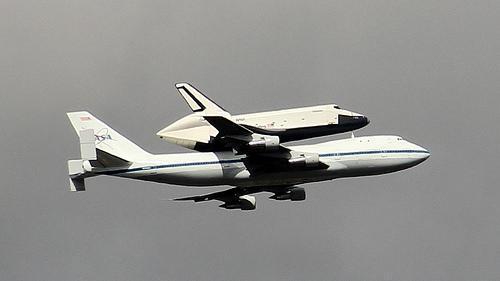How many engines does the plane have?
Give a very brief answer. 4. 